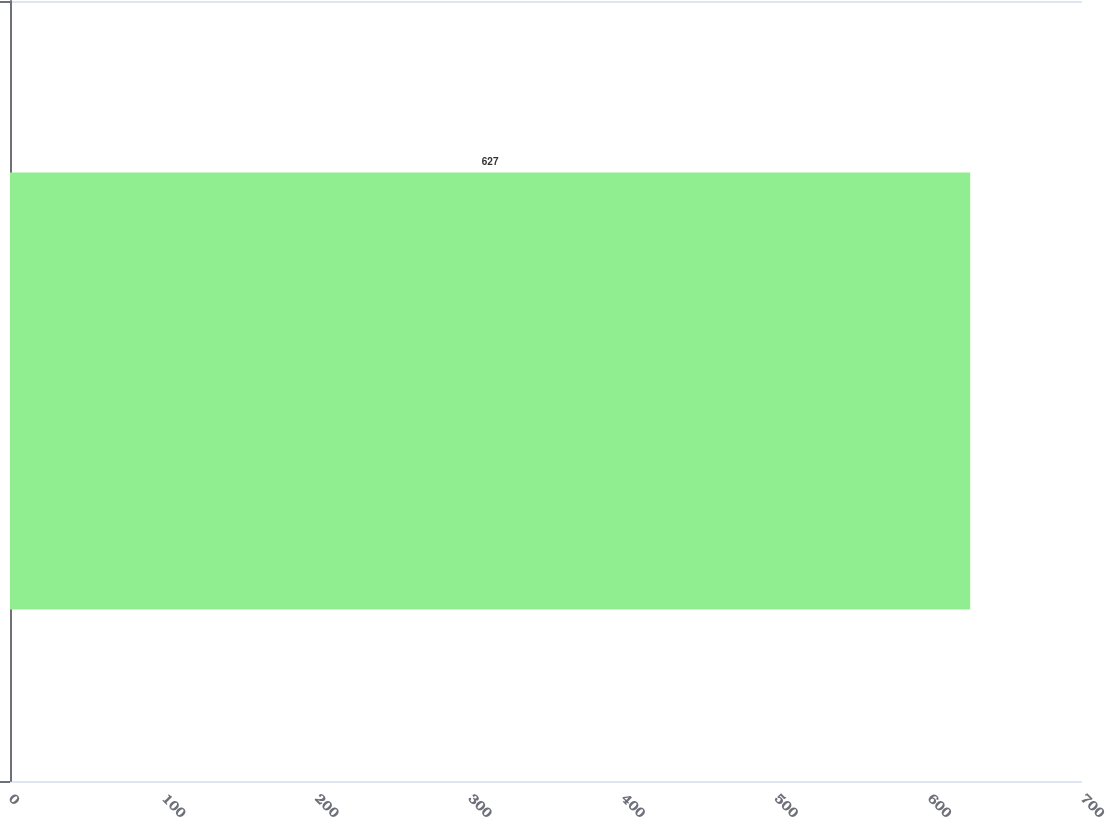Convert chart to OTSL. <chart><loc_0><loc_0><loc_500><loc_500><bar_chart><ecel><nl><fcel>627<nl></chart> 